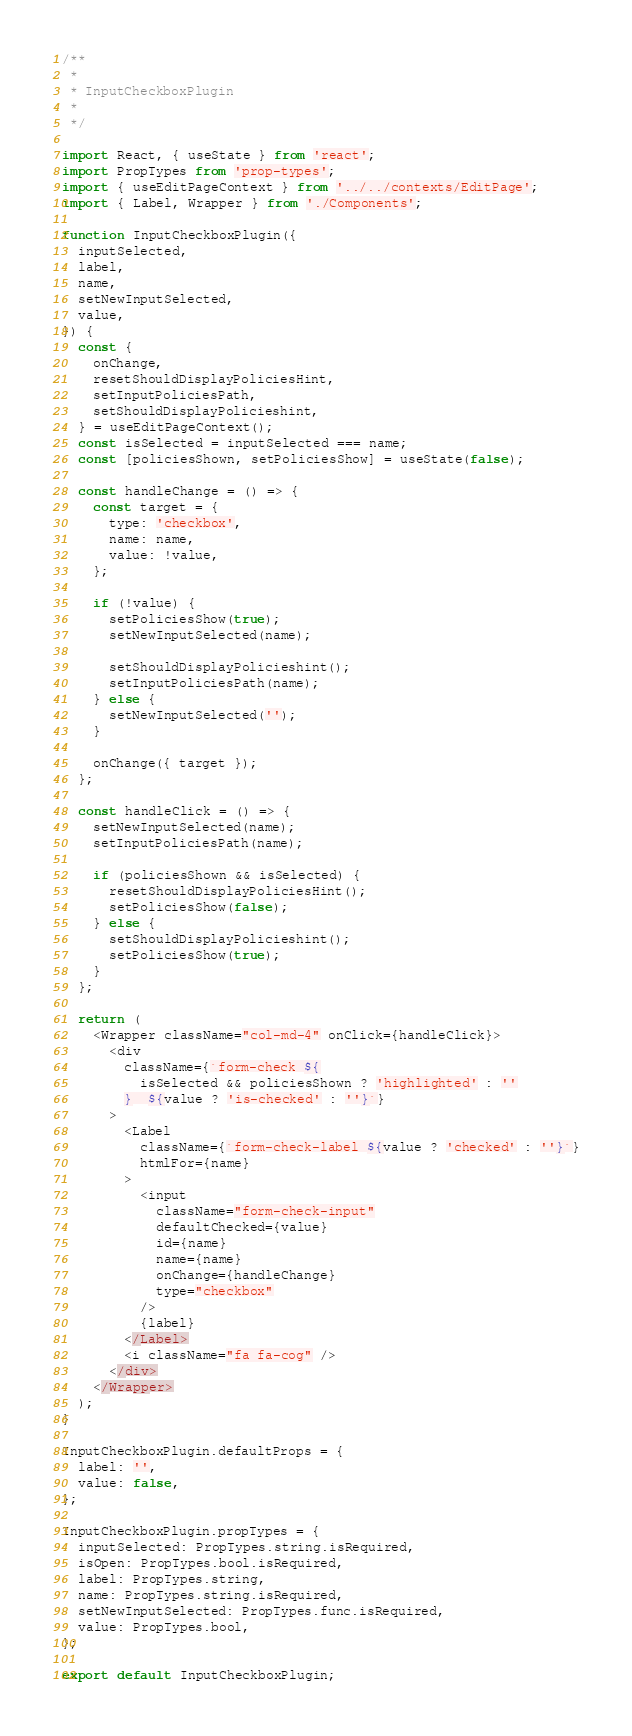Convert code to text. <code><loc_0><loc_0><loc_500><loc_500><_JavaScript_>/**
 *
 * InputCheckboxPlugin
 *
 */

import React, { useState } from 'react';
import PropTypes from 'prop-types';
import { useEditPageContext } from '../../contexts/EditPage';
import { Label, Wrapper } from './Components';

function InputCheckboxPlugin({
  inputSelected,
  label,
  name,
  setNewInputSelected,
  value,
}) {
  const {
    onChange,
    resetShouldDisplayPoliciesHint,
    setInputPoliciesPath,
    setShouldDisplayPolicieshint,
  } = useEditPageContext();
  const isSelected = inputSelected === name;
  const [policiesShown, setPoliciesShow] = useState(false);

  const handleChange = () => {
    const target = {
      type: 'checkbox',
      name: name,
      value: !value,
    };

    if (!value) {
      setPoliciesShow(true);
      setNewInputSelected(name);

      setShouldDisplayPolicieshint();
      setInputPoliciesPath(name);
    } else {
      setNewInputSelected('');
    }

    onChange({ target });
  };

  const handleClick = () => {
    setNewInputSelected(name);
    setInputPoliciesPath(name);

    if (policiesShown && isSelected) {
      resetShouldDisplayPoliciesHint();
      setPoliciesShow(false);
    } else {
      setShouldDisplayPolicieshint();
      setPoliciesShow(true);
    }
  };

  return (
    <Wrapper className="col-md-4" onClick={handleClick}>
      <div
        className={`form-check ${
          isSelected && policiesShown ? 'highlighted' : ''
        }  ${value ? 'is-checked' : ''}`}
      >
        <Label
          className={`form-check-label ${value ? 'checked' : ''}`}
          htmlFor={name}
        >
          <input
            className="form-check-input"
            defaultChecked={value}
            id={name}
            name={name}
            onChange={handleChange}
            type="checkbox"
          />
          {label}
        </Label>
        <i className="fa fa-cog" />
      </div>
    </Wrapper>
  );
}

InputCheckboxPlugin.defaultProps = {
  label: '',
  value: false,
};

InputCheckboxPlugin.propTypes = {
  inputSelected: PropTypes.string.isRequired,
  isOpen: PropTypes.bool.isRequired,
  label: PropTypes.string,
  name: PropTypes.string.isRequired,
  setNewInputSelected: PropTypes.func.isRequired,
  value: PropTypes.bool,
};

export default InputCheckboxPlugin;
</code> 